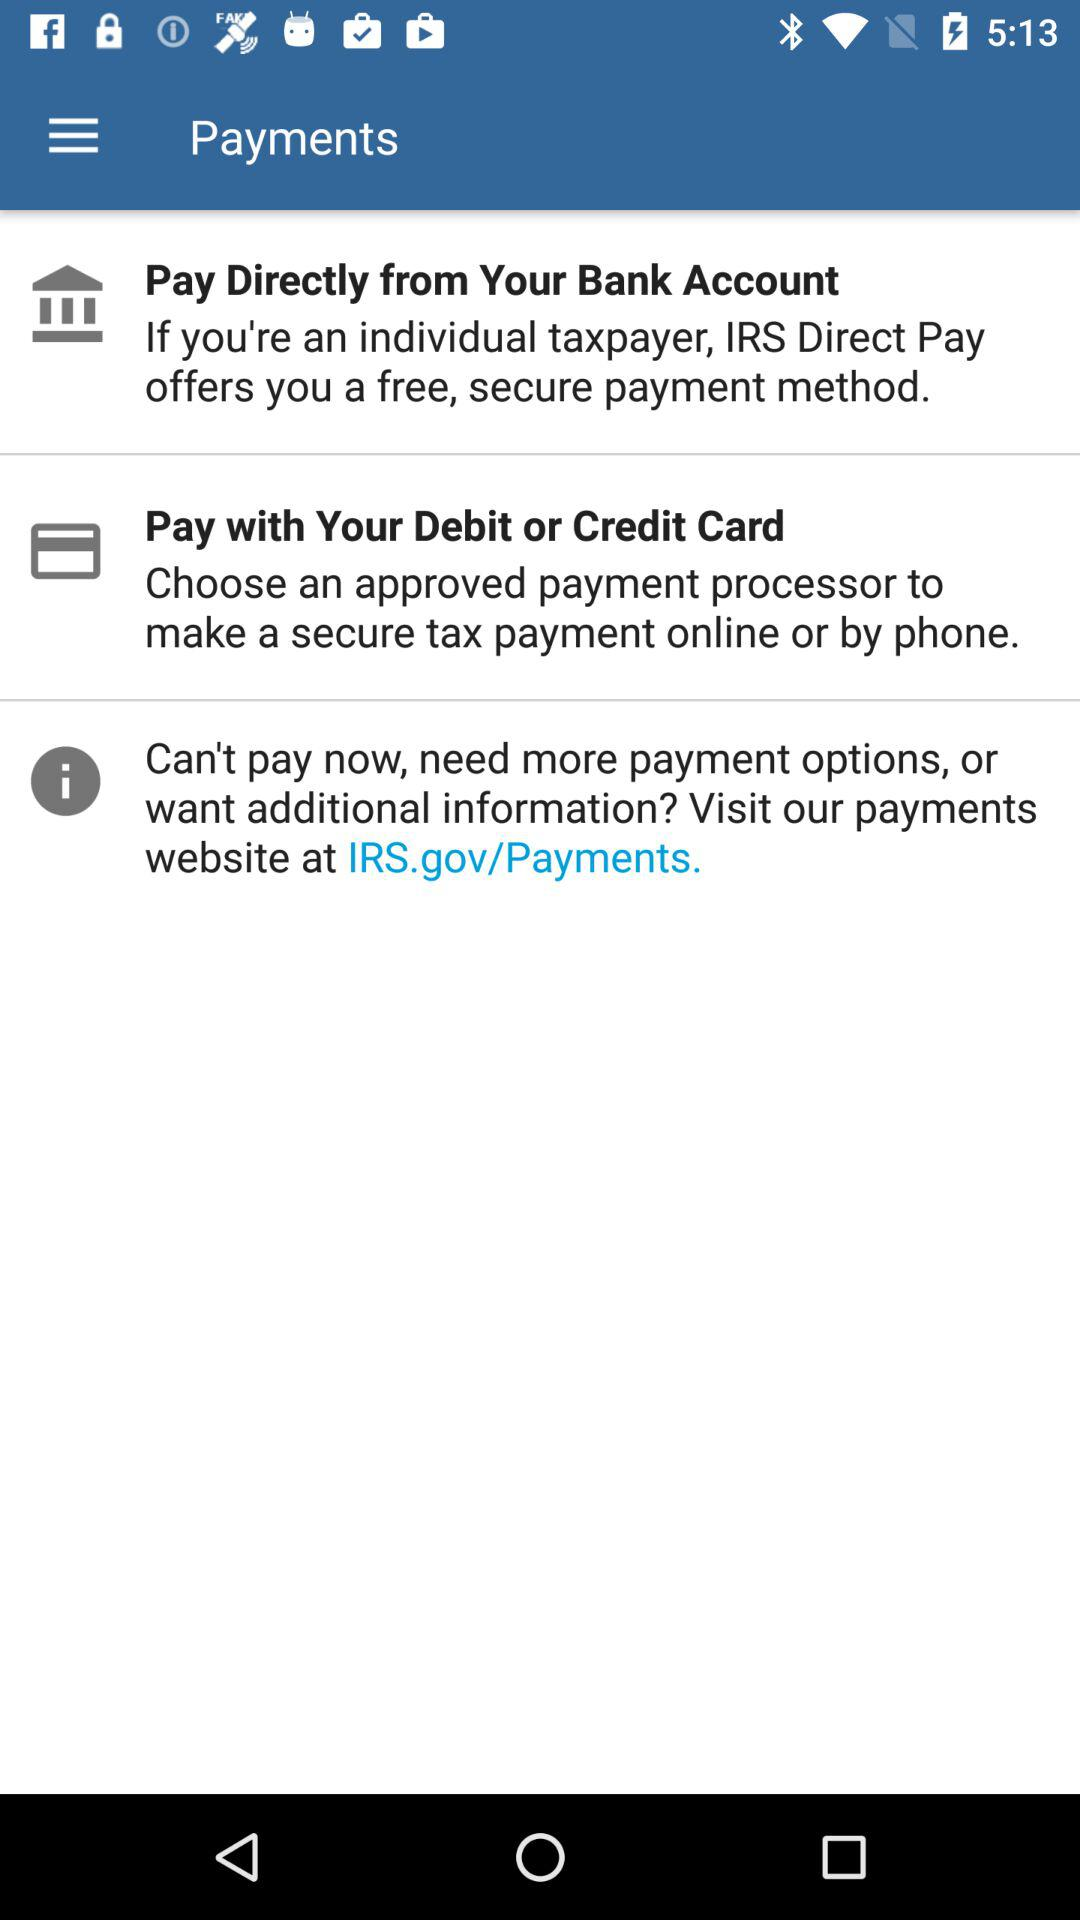Which payment option has been chosen?
When the provided information is insufficient, respond with <no answer>. <no answer> 